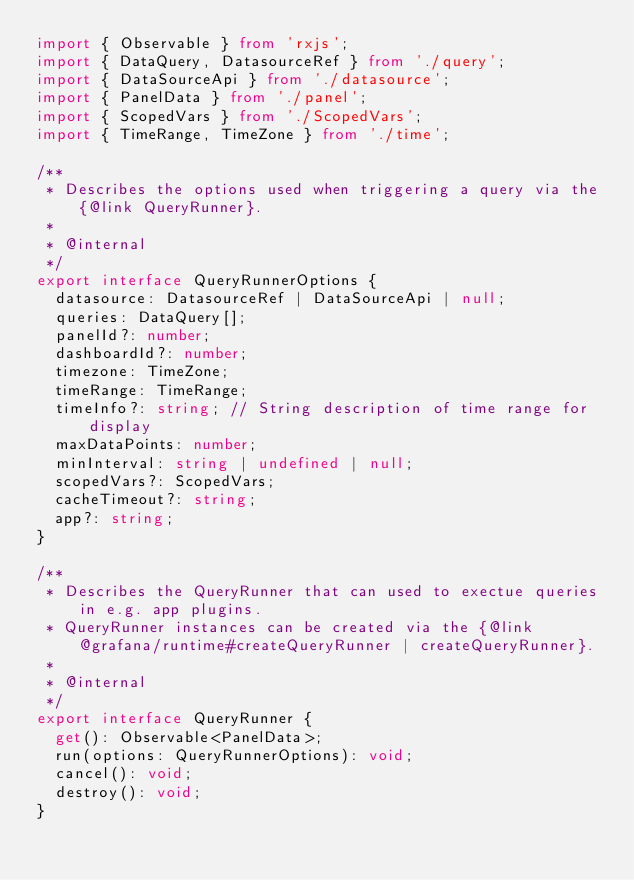<code> <loc_0><loc_0><loc_500><loc_500><_TypeScript_>import { Observable } from 'rxjs';
import { DataQuery, DatasourceRef } from './query';
import { DataSourceApi } from './datasource';
import { PanelData } from './panel';
import { ScopedVars } from './ScopedVars';
import { TimeRange, TimeZone } from './time';

/**
 * Describes the options used when triggering a query via the {@link QueryRunner}.
 *
 * @internal
 */
export interface QueryRunnerOptions {
  datasource: DatasourceRef | DataSourceApi | null;
  queries: DataQuery[];
  panelId?: number;
  dashboardId?: number;
  timezone: TimeZone;
  timeRange: TimeRange;
  timeInfo?: string; // String description of time range for display
  maxDataPoints: number;
  minInterval: string | undefined | null;
  scopedVars?: ScopedVars;
  cacheTimeout?: string;
  app?: string;
}

/**
 * Describes the QueryRunner that can used to exectue queries in e.g. app plugins.
 * QueryRunner instances can be created via the {@link @grafana/runtime#createQueryRunner | createQueryRunner}.
 *
 * @internal
 */
export interface QueryRunner {
  get(): Observable<PanelData>;
  run(options: QueryRunnerOptions): void;
  cancel(): void;
  destroy(): void;
}
</code> 